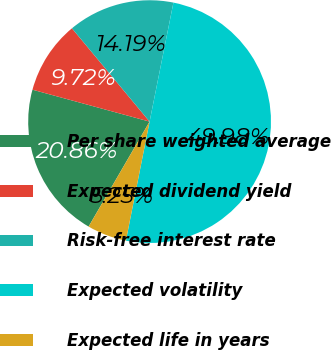Convert chart. <chart><loc_0><loc_0><loc_500><loc_500><pie_chart><fcel>Per share weighted average<fcel>Expected dividend yield<fcel>Risk-free interest rate<fcel>Expected volatility<fcel>Expected life in years<nl><fcel>20.86%<fcel>9.72%<fcel>14.19%<fcel>49.98%<fcel>5.25%<nl></chart> 